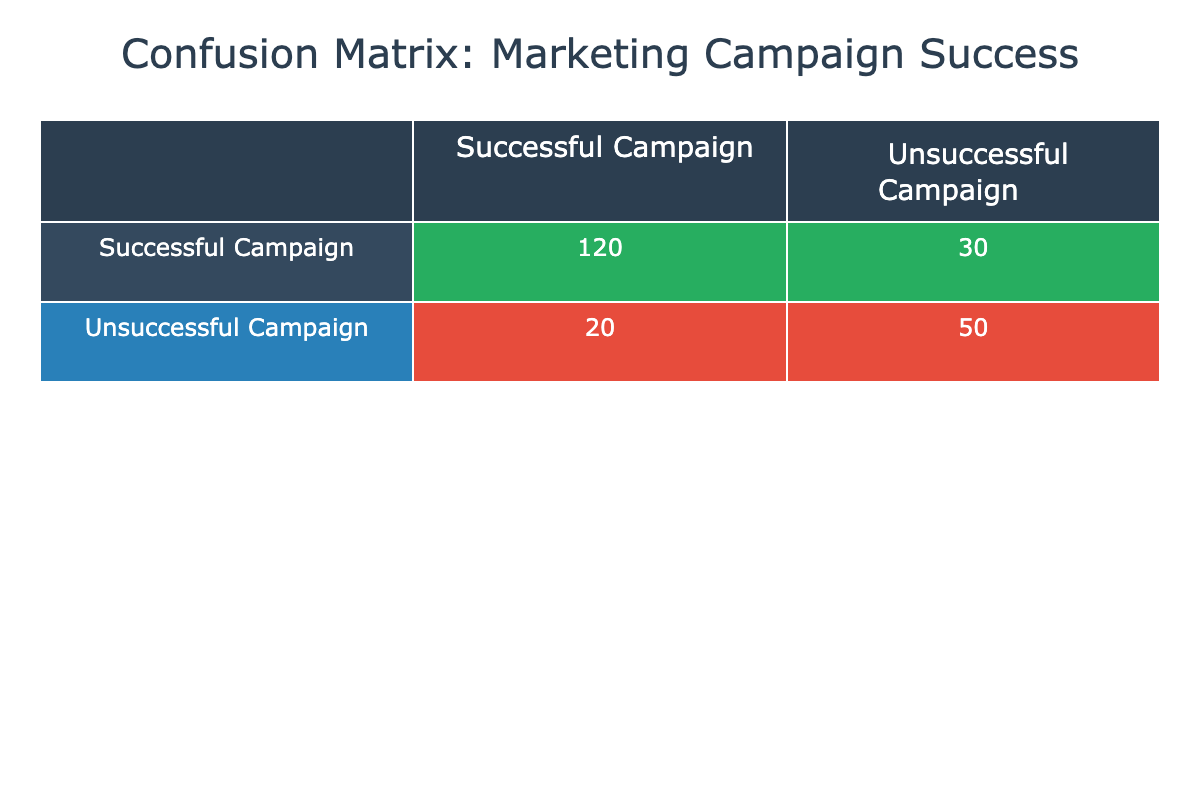What is the total number of successful campaigns? To find the total number of successful campaigns, we can look at the first row in the table. It shows that there are 120 successful campaigns and 20 unsuccessful campaigns that were predicted to be unsuccessful campaigns. Thus, the total successful campaigns are 120 + 20 = 140.
Answer: 140 What is the number of unsuccessful campaigns that were incorrectly predicted as successful? From the table, we see that there are 30 campaigns that were successful but predicted as unsuccessful. This value is directly available in the first row under the column for unsuccessful campaigns.
Answer: 30 What percentage of the total campaigns were successful? To find the percentage of successful campaigns, we first calculate the total campaigns which is the sum of all values in the table: 120 + 30 + 20 + 50 = 220. Then, the successful campaigns total to 140 (120 successful + 20 incorrectly predicted). The percentage of successful campaigns is (140 / 220) * 100 = 63.64%.
Answer: 63.64% Are there more successful campaigns than unsuccessful campaigns in this data? To answer this, we compare the total successful campaigns (which is 140) versus total unsuccessful campaigns (which is 100: 30 predicted as successful + 50 actually unsuccessful). Since 140 is greater than 100, the statement is true.
Answer: Yes What is the false negative rate for the campaigns? The false negative rate is calculated as the number of unsuccessful campaigns that were predicted to be successful (30) divided by the total actual unsuccessful campaigns (which is the sum of campaigns that were unsuccessful: 30 + 50 = 80). So, the false negative rate is 30 / 80 = 0.375 or 37.5%.
Answer: 37.5% How many campaigns were correctly predicted as unsuccessful? From the confusion matrix, we can see that the second cell in the second row indicates that 50 campaigns were correctly predicted as unsuccessful. This value is directly available from the table.
Answer: 50 What is the difference between the number of successful campaigns and the number of campaigns incorrectly predicted as unsuccessful? The number of successful campaigns is 120, and the number of campaigns incorrectly predicted as unsuccessful is 30. The difference is 120 - 30 = 90.
Answer: 90 What is the total number of campaigns predicted as successful? To find the total number of predicted successful campaigns, we need to sum the successful campaigns that were predicted successfully (120) and the ones that were predicted incorrectly (20). Thus, the total predicted as successful is 120 + 20 = 140.
Answer: 140 How many campaigns were actually unsuccessful but predicted to be successful? This value can be found in the table under actual unsuccessful but predicted as successful, which is 20. This is directly visible in the table.
Answer: 20 